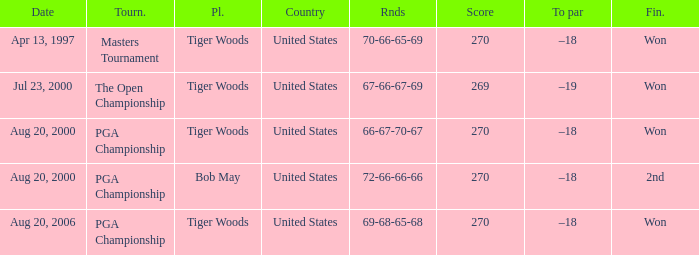What players finished 2nd? Bob May. 